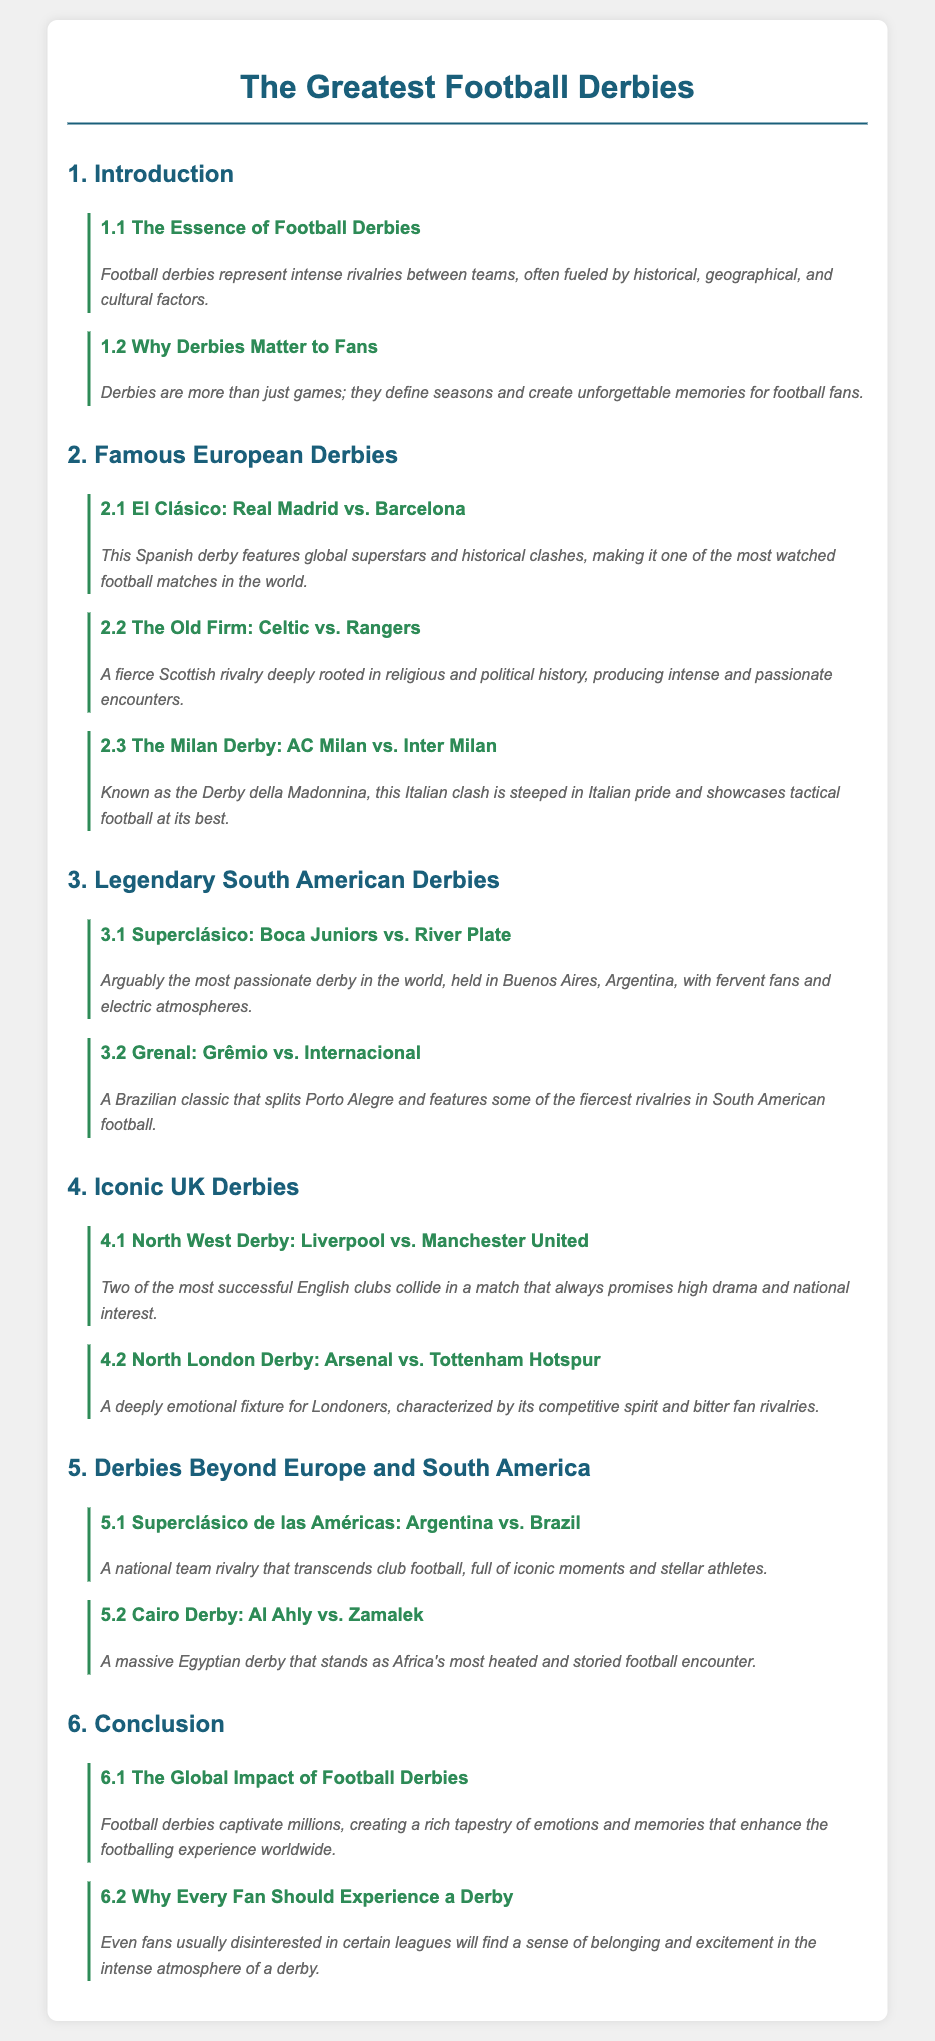what is the title of the document? The title of the document is provided in the <title> tag of the HTML and is "The Greatest Football Derbies".
Answer: The Greatest Football Derbies who are the teams in El Clásico? El Clásico features Real Madrid and Barcelona as mentioned in the section for Famous European Derbies.
Answer: Real Madrid vs. Barcelona which derby is known as the Superclásico? The Superclásico is another name for the derby between Boca Juniors and River Plate in South America.
Answer: Boca Juniors vs. River Plate how many famous European derbies are listed? The section on Famous European Derbies lists three specific derbies.
Answer: Three what is a key factor that makes the North West Derby significant? The North West Derby is significant due to the rivalry between two of the most successful English clubs, Liverpool and Manchester United.
Answer: High drama and national interest which derby is described as the most passionate in the world? The document explicitly identifies the Superclásico as the most passionate derby in the world.
Answer: Superclásico what section discusses derbies beyond Europe and South America? The section titled "Derbies Beyond Europe and South America" discusses these derbies.
Answer: Derbies Beyond Europe and South America what is the essence of football derbies according to the document? The essence of football derbies is described as intense rivalries fueled by various factors such as historical, geographical, and cultural influences.
Answer: Intense rivalries what emotional aspect do football derbies create for fans? Football derbies create unforgettable memories for fans, as highlighted in the document.
Answer: Unforgettable memories 